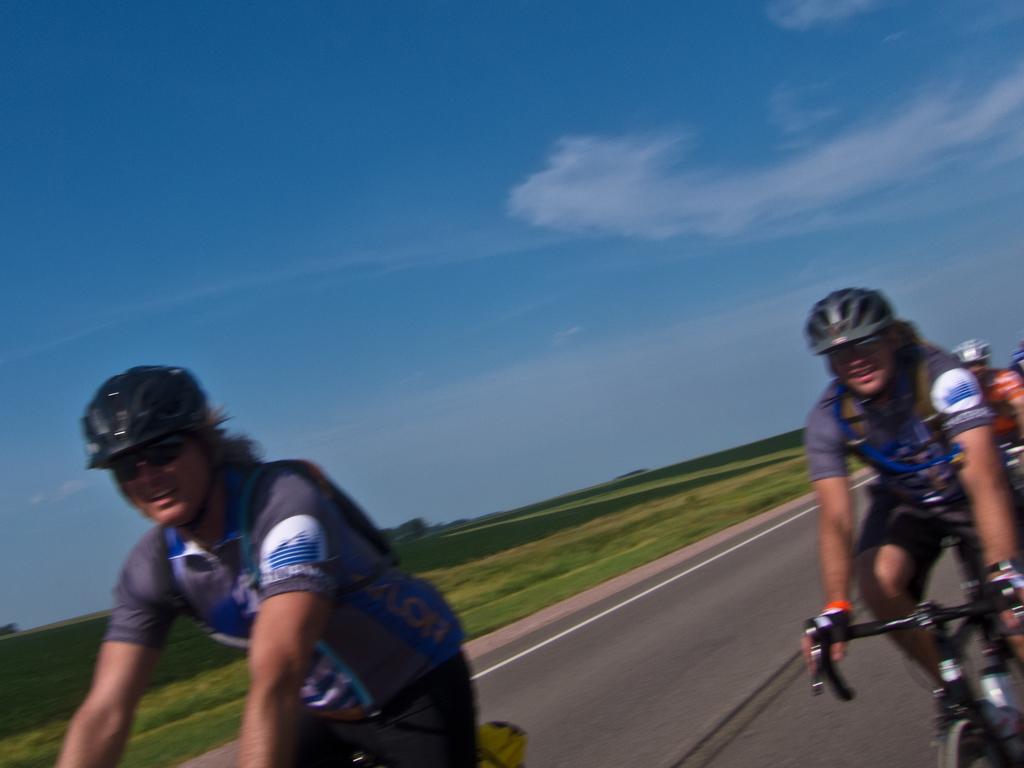In one or two sentences, can you explain what this image depicts? In this image we can see some people riding bicycles on the road. We can also see some plants and the sky which looks cloudy. 